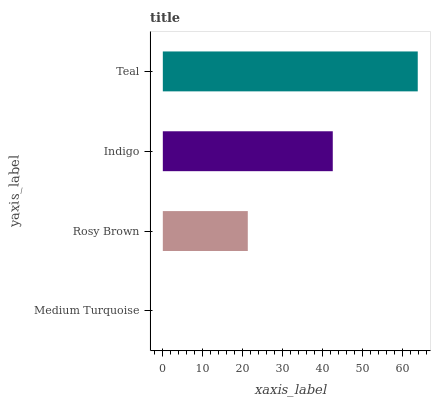Is Medium Turquoise the minimum?
Answer yes or no. Yes. Is Teal the maximum?
Answer yes or no. Yes. Is Rosy Brown the minimum?
Answer yes or no. No. Is Rosy Brown the maximum?
Answer yes or no. No. Is Rosy Brown greater than Medium Turquoise?
Answer yes or no. Yes. Is Medium Turquoise less than Rosy Brown?
Answer yes or no. Yes. Is Medium Turquoise greater than Rosy Brown?
Answer yes or no. No. Is Rosy Brown less than Medium Turquoise?
Answer yes or no. No. Is Indigo the high median?
Answer yes or no. Yes. Is Rosy Brown the low median?
Answer yes or no. Yes. Is Rosy Brown the high median?
Answer yes or no. No. Is Indigo the low median?
Answer yes or no. No. 